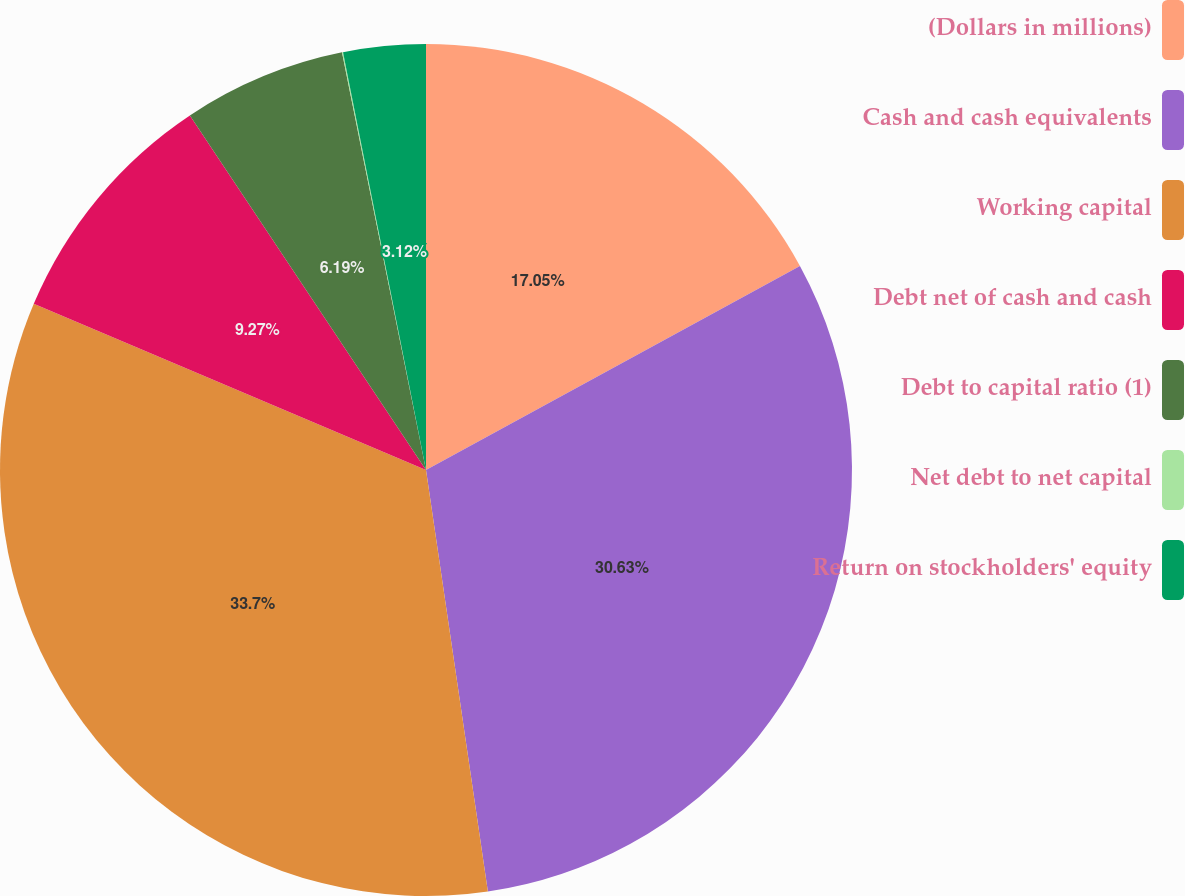<chart> <loc_0><loc_0><loc_500><loc_500><pie_chart><fcel>(Dollars in millions)<fcel>Cash and cash equivalents<fcel>Working capital<fcel>Debt net of cash and cash<fcel>Debt to capital ratio (1)<fcel>Net debt to net capital<fcel>Return on stockholders' equity<nl><fcel>17.05%<fcel>30.63%<fcel>33.7%<fcel>9.27%<fcel>6.19%<fcel>0.04%<fcel>3.12%<nl></chart> 